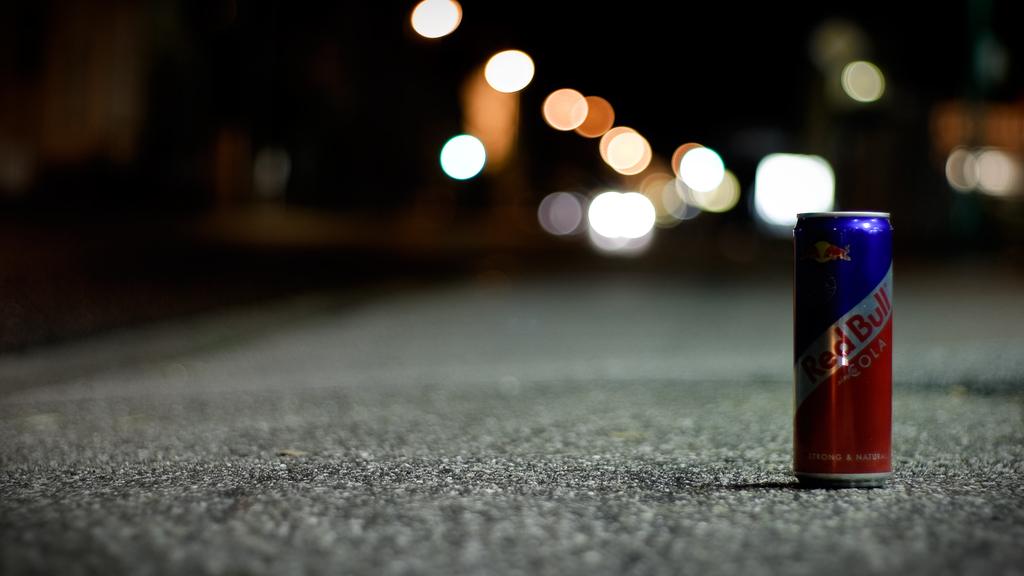What's that can got in it?
Your answer should be very brief. Red bull. What is the brand of drink?
Provide a succinct answer. Red bull. 